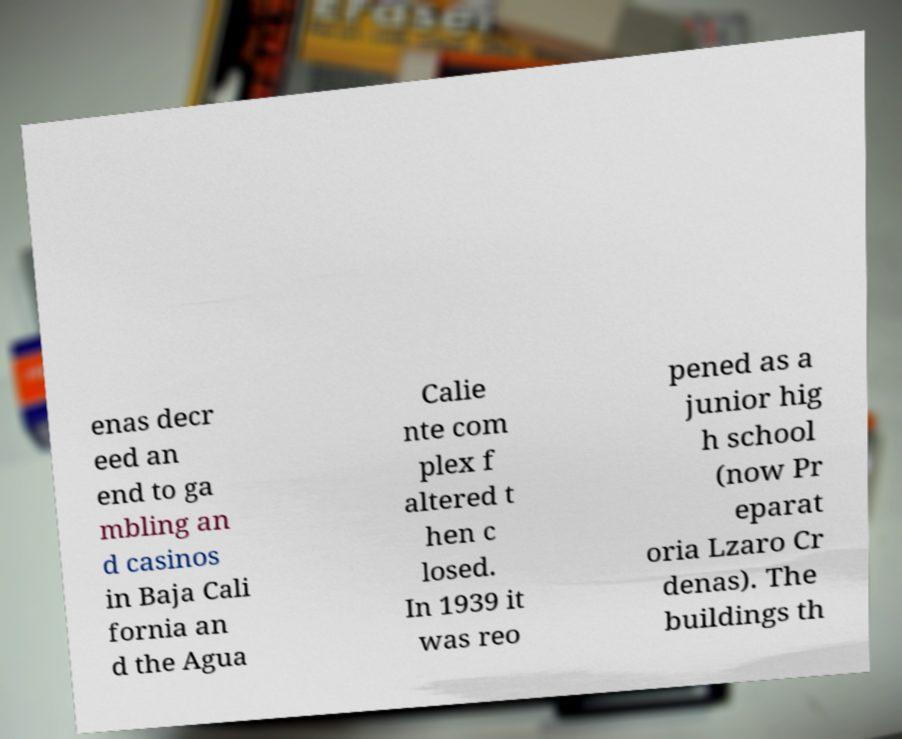Please read and relay the text visible in this image. What does it say? enas decr eed an end to ga mbling an d casinos in Baja Cali fornia an d the Agua Calie nte com plex f altered t hen c losed. In 1939 it was reo pened as a junior hig h school (now Pr eparat oria Lzaro Cr denas). The buildings th 